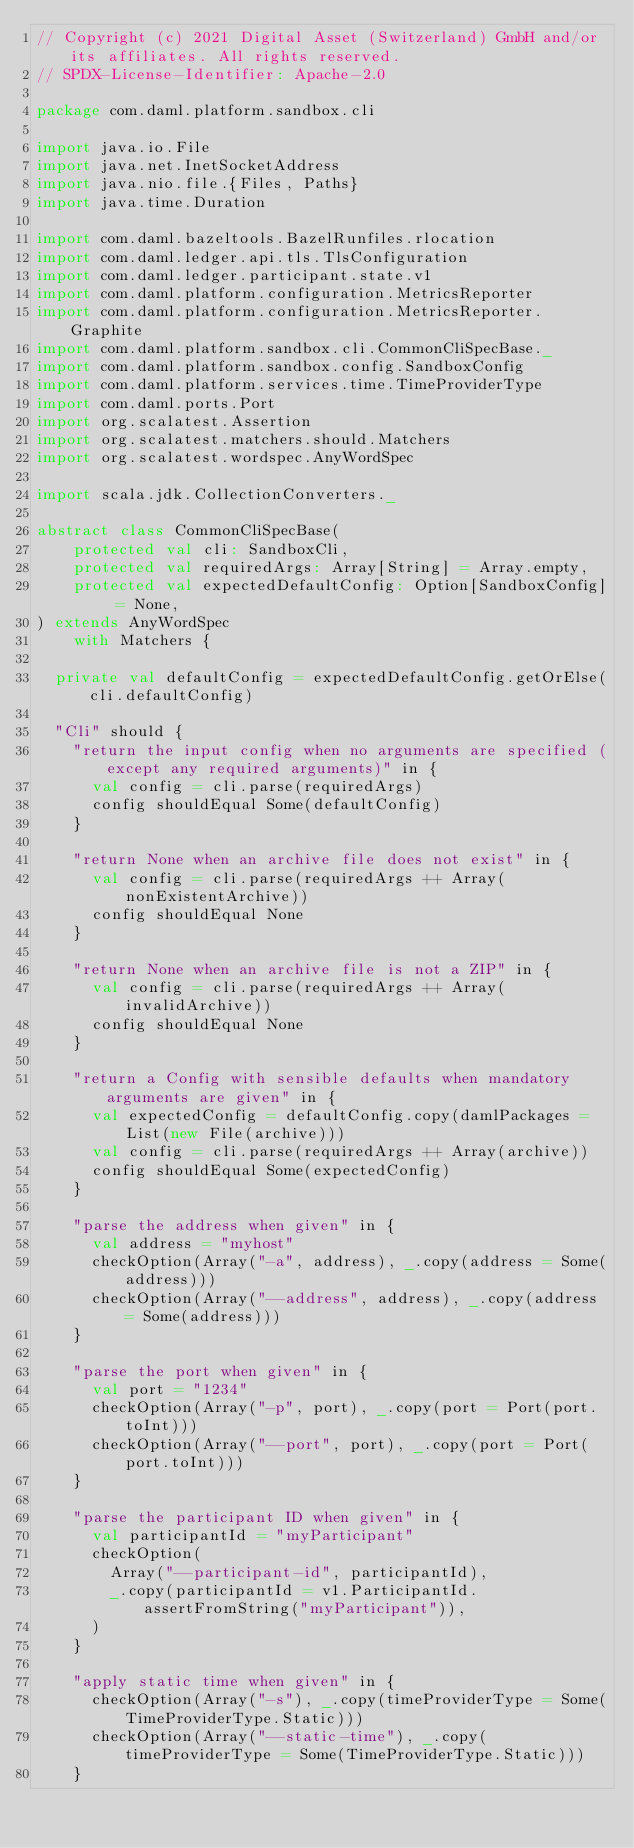Convert code to text. <code><loc_0><loc_0><loc_500><loc_500><_Scala_>// Copyright (c) 2021 Digital Asset (Switzerland) GmbH and/or its affiliates. All rights reserved.
// SPDX-License-Identifier: Apache-2.0

package com.daml.platform.sandbox.cli

import java.io.File
import java.net.InetSocketAddress
import java.nio.file.{Files, Paths}
import java.time.Duration

import com.daml.bazeltools.BazelRunfiles.rlocation
import com.daml.ledger.api.tls.TlsConfiguration
import com.daml.ledger.participant.state.v1
import com.daml.platform.configuration.MetricsReporter
import com.daml.platform.configuration.MetricsReporter.Graphite
import com.daml.platform.sandbox.cli.CommonCliSpecBase._
import com.daml.platform.sandbox.config.SandboxConfig
import com.daml.platform.services.time.TimeProviderType
import com.daml.ports.Port
import org.scalatest.Assertion
import org.scalatest.matchers.should.Matchers
import org.scalatest.wordspec.AnyWordSpec

import scala.jdk.CollectionConverters._

abstract class CommonCliSpecBase(
    protected val cli: SandboxCli,
    protected val requiredArgs: Array[String] = Array.empty,
    protected val expectedDefaultConfig: Option[SandboxConfig] = None,
) extends AnyWordSpec
    with Matchers {

  private val defaultConfig = expectedDefaultConfig.getOrElse(cli.defaultConfig)

  "Cli" should {
    "return the input config when no arguments are specified (except any required arguments)" in {
      val config = cli.parse(requiredArgs)
      config shouldEqual Some(defaultConfig)
    }

    "return None when an archive file does not exist" in {
      val config = cli.parse(requiredArgs ++ Array(nonExistentArchive))
      config shouldEqual None
    }

    "return None when an archive file is not a ZIP" in {
      val config = cli.parse(requiredArgs ++ Array(invalidArchive))
      config shouldEqual None
    }

    "return a Config with sensible defaults when mandatory arguments are given" in {
      val expectedConfig = defaultConfig.copy(damlPackages = List(new File(archive)))
      val config = cli.parse(requiredArgs ++ Array(archive))
      config shouldEqual Some(expectedConfig)
    }

    "parse the address when given" in {
      val address = "myhost"
      checkOption(Array("-a", address), _.copy(address = Some(address)))
      checkOption(Array("--address", address), _.copy(address = Some(address)))
    }

    "parse the port when given" in {
      val port = "1234"
      checkOption(Array("-p", port), _.copy(port = Port(port.toInt)))
      checkOption(Array("--port", port), _.copy(port = Port(port.toInt)))
    }

    "parse the participant ID when given" in {
      val participantId = "myParticipant"
      checkOption(
        Array("--participant-id", participantId),
        _.copy(participantId = v1.ParticipantId.assertFromString("myParticipant")),
      )
    }

    "apply static time when given" in {
      checkOption(Array("-s"), _.copy(timeProviderType = Some(TimeProviderType.Static)))
      checkOption(Array("--static-time"), _.copy(timeProviderType = Some(TimeProviderType.Static)))
    }
</code> 